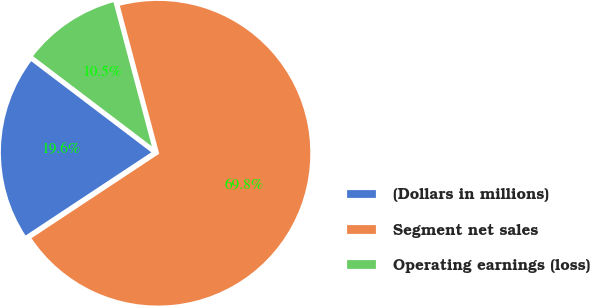Convert chart. <chart><loc_0><loc_0><loc_500><loc_500><pie_chart><fcel>(Dollars in millions)<fcel>Segment net sales<fcel>Operating earnings (loss)<nl><fcel>19.63%<fcel>69.84%<fcel>10.53%<nl></chart> 